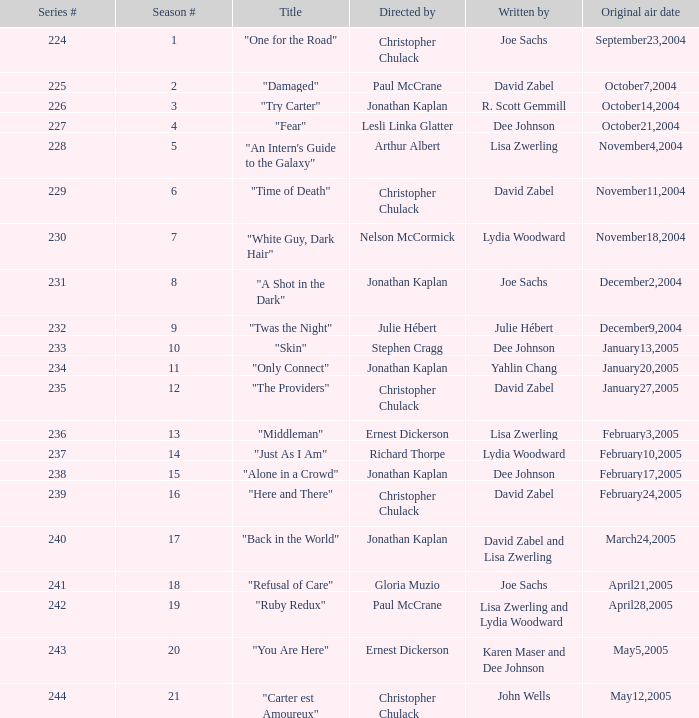Name who wrote the episode directed by arthur albert Lisa Zwerling. 